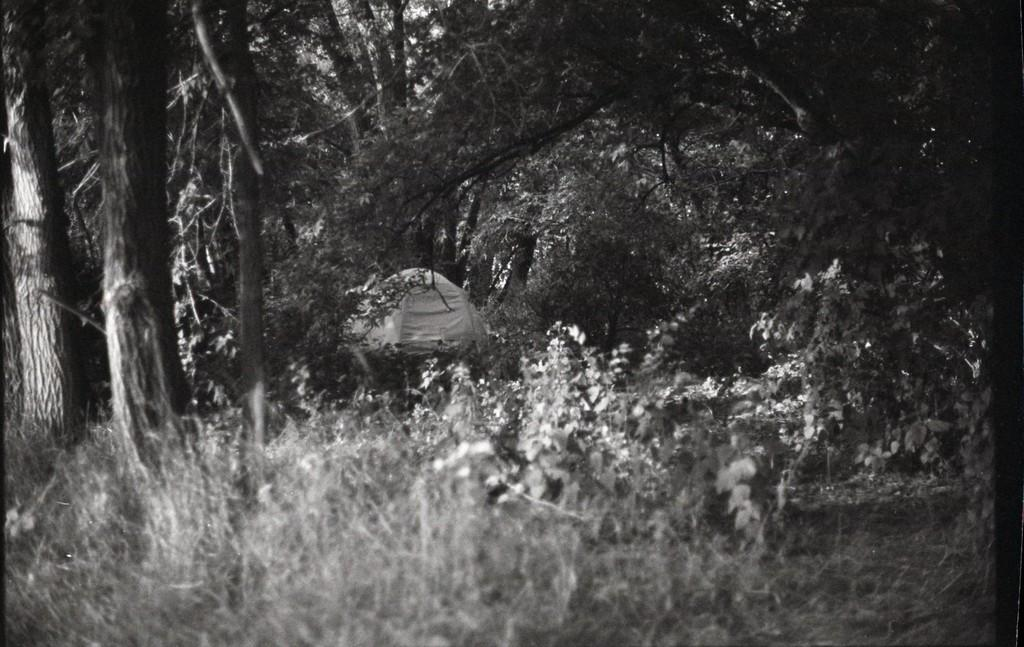What type of shelter is visible in the picture? There is a tent in the picture. What can be seen in the background of the picture? There are many trees present in the picture. How many oranges are hanging from the trees in the picture? There is no mention of oranges in the picture; it only features a tent and trees. 